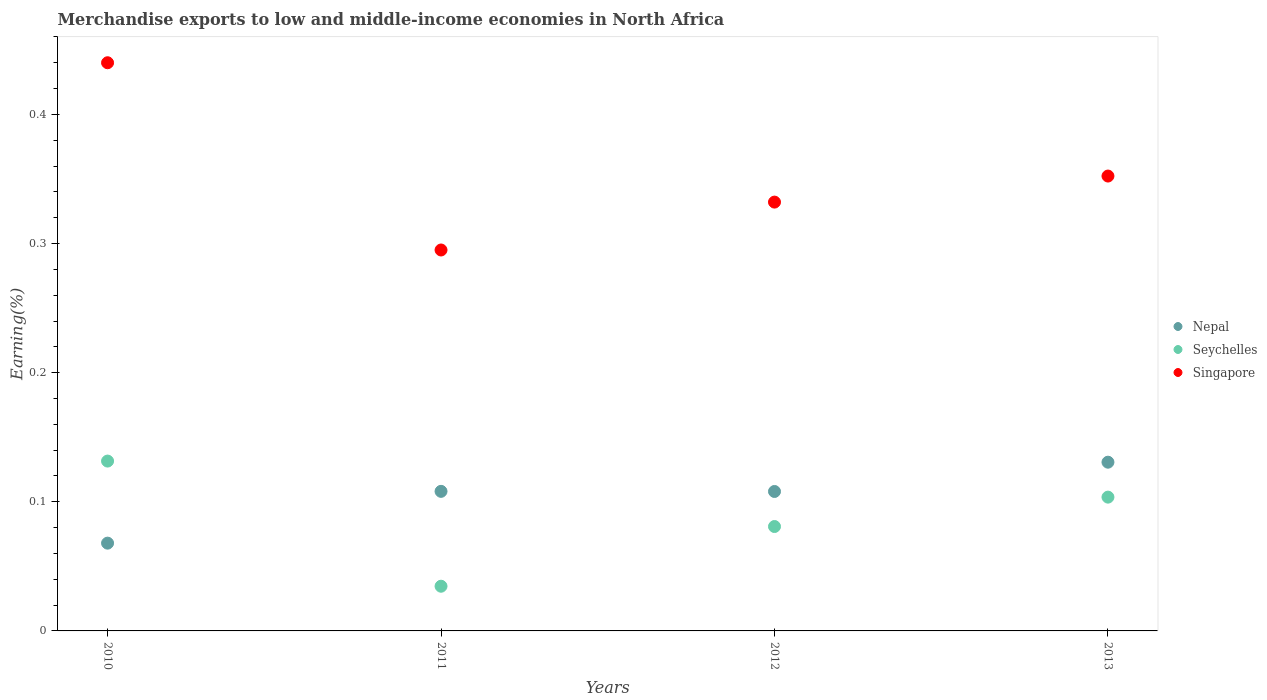How many different coloured dotlines are there?
Keep it short and to the point. 3. What is the percentage of amount earned from merchandise exports in Seychelles in 2013?
Your response must be concise. 0.1. Across all years, what is the maximum percentage of amount earned from merchandise exports in Singapore?
Your answer should be compact. 0.44. Across all years, what is the minimum percentage of amount earned from merchandise exports in Seychelles?
Ensure brevity in your answer.  0.03. In which year was the percentage of amount earned from merchandise exports in Nepal minimum?
Make the answer very short. 2010. What is the total percentage of amount earned from merchandise exports in Singapore in the graph?
Offer a very short reply. 1.42. What is the difference between the percentage of amount earned from merchandise exports in Seychelles in 2012 and that in 2013?
Offer a very short reply. -0.02. What is the difference between the percentage of amount earned from merchandise exports in Seychelles in 2013 and the percentage of amount earned from merchandise exports in Singapore in 2012?
Keep it short and to the point. -0.23. What is the average percentage of amount earned from merchandise exports in Nepal per year?
Ensure brevity in your answer.  0.1. In the year 2010, what is the difference between the percentage of amount earned from merchandise exports in Nepal and percentage of amount earned from merchandise exports in Singapore?
Ensure brevity in your answer.  -0.37. In how many years, is the percentage of amount earned from merchandise exports in Seychelles greater than 0.2 %?
Ensure brevity in your answer.  0. What is the ratio of the percentage of amount earned from merchandise exports in Singapore in 2011 to that in 2013?
Provide a short and direct response. 0.84. Is the difference between the percentage of amount earned from merchandise exports in Nepal in 2011 and 2013 greater than the difference between the percentage of amount earned from merchandise exports in Singapore in 2011 and 2013?
Offer a very short reply. Yes. What is the difference between the highest and the second highest percentage of amount earned from merchandise exports in Singapore?
Ensure brevity in your answer.  0.09. What is the difference between the highest and the lowest percentage of amount earned from merchandise exports in Nepal?
Make the answer very short. 0.06. Is the sum of the percentage of amount earned from merchandise exports in Singapore in 2010 and 2011 greater than the maximum percentage of amount earned from merchandise exports in Seychelles across all years?
Keep it short and to the point. Yes. Is it the case that in every year, the sum of the percentage of amount earned from merchandise exports in Seychelles and percentage of amount earned from merchandise exports in Nepal  is greater than the percentage of amount earned from merchandise exports in Singapore?
Offer a terse response. No. Does the percentage of amount earned from merchandise exports in Singapore monotonically increase over the years?
Give a very brief answer. No. How many dotlines are there?
Offer a terse response. 3. How many years are there in the graph?
Your response must be concise. 4. Are the values on the major ticks of Y-axis written in scientific E-notation?
Make the answer very short. No. Does the graph contain grids?
Your response must be concise. No. Where does the legend appear in the graph?
Offer a very short reply. Center right. What is the title of the graph?
Your response must be concise. Merchandise exports to low and middle-income economies in North Africa. What is the label or title of the X-axis?
Ensure brevity in your answer.  Years. What is the label or title of the Y-axis?
Offer a very short reply. Earning(%). What is the Earning(%) in Nepal in 2010?
Provide a short and direct response. 0.07. What is the Earning(%) in Seychelles in 2010?
Make the answer very short. 0.13. What is the Earning(%) of Singapore in 2010?
Your response must be concise. 0.44. What is the Earning(%) in Nepal in 2011?
Ensure brevity in your answer.  0.11. What is the Earning(%) in Seychelles in 2011?
Offer a very short reply. 0.03. What is the Earning(%) in Singapore in 2011?
Keep it short and to the point. 0.3. What is the Earning(%) of Nepal in 2012?
Your response must be concise. 0.11. What is the Earning(%) of Seychelles in 2012?
Provide a short and direct response. 0.08. What is the Earning(%) in Singapore in 2012?
Provide a short and direct response. 0.33. What is the Earning(%) of Nepal in 2013?
Ensure brevity in your answer.  0.13. What is the Earning(%) in Seychelles in 2013?
Your answer should be very brief. 0.1. What is the Earning(%) of Singapore in 2013?
Ensure brevity in your answer.  0.35. Across all years, what is the maximum Earning(%) in Nepal?
Give a very brief answer. 0.13. Across all years, what is the maximum Earning(%) of Seychelles?
Make the answer very short. 0.13. Across all years, what is the maximum Earning(%) in Singapore?
Offer a very short reply. 0.44. Across all years, what is the minimum Earning(%) of Nepal?
Make the answer very short. 0.07. Across all years, what is the minimum Earning(%) of Seychelles?
Provide a short and direct response. 0.03. Across all years, what is the minimum Earning(%) in Singapore?
Your response must be concise. 0.3. What is the total Earning(%) in Nepal in the graph?
Your response must be concise. 0.41. What is the total Earning(%) in Seychelles in the graph?
Ensure brevity in your answer.  0.35. What is the total Earning(%) of Singapore in the graph?
Your response must be concise. 1.42. What is the difference between the Earning(%) of Nepal in 2010 and that in 2011?
Give a very brief answer. -0.04. What is the difference between the Earning(%) of Seychelles in 2010 and that in 2011?
Provide a succinct answer. 0.1. What is the difference between the Earning(%) in Singapore in 2010 and that in 2011?
Ensure brevity in your answer.  0.14. What is the difference between the Earning(%) of Nepal in 2010 and that in 2012?
Provide a succinct answer. -0.04. What is the difference between the Earning(%) in Seychelles in 2010 and that in 2012?
Give a very brief answer. 0.05. What is the difference between the Earning(%) of Singapore in 2010 and that in 2012?
Ensure brevity in your answer.  0.11. What is the difference between the Earning(%) of Nepal in 2010 and that in 2013?
Ensure brevity in your answer.  -0.06. What is the difference between the Earning(%) in Seychelles in 2010 and that in 2013?
Offer a very short reply. 0.03. What is the difference between the Earning(%) of Singapore in 2010 and that in 2013?
Ensure brevity in your answer.  0.09. What is the difference between the Earning(%) in Nepal in 2011 and that in 2012?
Your answer should be compact. 0. What is the difference between the Earning(%) in Seychelles in 2011 and that in 2012?
Make the answer very short. -0.05. What is the difference between the Earning(%) of Singapore in 2011 and that in 2012?
Provide a succinct answer. -0.04. What is the difference between the Earning(%) of Nepal in 2011 and that in 2013?
Keep it short and to the point. -0.02. What is the difference between the Earning(%) of Seychelles in 2011 and that in 2013?
Ensure brevity in your answer.  -0.07. What is the difference between the Earning(%) in Singapore in 2011 and that in 2013?
Ensure brevity in your answer.  -0.06. What is the difference between the Earning(%) of Nepal in 2012 and that in 2013?
Make the answer very short. -0.02. What is the difference between the Earning(%) of Seychelles in 2012 and that in 2013?
Your answer should be very brief. -0.02. What is the difference between the Earning(%) in Singapore in 2012 and that in 2013?
Provide a short and direct response. -0.02. What is the difference between the Earning(%) in Nepal in 2010 and the Earning(%) in Seychelles in 2011?
Your response must be concise. 0.03. What is the difference between the Earning(%) in Nepal in 2010 and the Earning(%) in Singapore in 2011?
Your answer should be very brief. -0.23. What is the difference between the Earning(%) of Seychelles in 2010 and the Earning(%) of Singapore in 2011?
Provide a succinct answer. -0.16. What is the difference between the Earning(%) in Nepal in 2010 and the Earning(%) in Seychelles in 2012?
Your answer should be very brief. -0.01. What is the difference between the Earning(%) of Nepal in 2010 and the Earning(%) of Singapore in 2012?
Keep it short and to the point. -0.26. What is the difference between the Earning(%) in Seychelles in 2010 and the Earning(%) in Singapore in 2012?
Provide a short and direct response. -0.2. What is the difference between the Earning(%) of Nepal in 2010 and the Earning(%) of Seychelles in 2013?
Keep it short and to the point. -0.04. What is the difference between the Earning(%) in Nepal in 2010 and the Earning(%) in Singapore in 2013?
Keep it short and to the point. -0.28. What is the difference between the Earning(%) in Seychelles in 2010 and the Earning(%) in Singapore in 2013?
Your answer should be compact. -0.22. What is the difference between the Earning(%) of Nepal in 2011 and the Earning(%) of Seychelles in 2012?
Offer a very short reply. 0.03. What is the difference between the Earning(%) of Nepal in 2011 and the Earning(%) of Singapore in 2012?
Make the answer very short. -0.22. What is the difference between the Earning(%) in Seychelles in 2011 and the Earning(%) in Singapore in 2012?
Offer a very short reply. -0.3. What is the difference between the Earning(%) of Nepal in 2011 and the Earning(%) of Seychelles in 2013?
Offer a very short reply. 0. What is the difference between the Earning(%) in Nepal in 2011 and the Earning(%) in Singapore in 2013?
Your answer should be very brief. -0.24. What is the difference between the Earning(%) in Seychelles in 2011 and the Earning(%) in Singapore in 2013?
Offer a terse response. -0.32. What is the difference between the Earning(%) in Nepal in 2012 and the Earning(%) in Seychelles in 2013?
Keep it short and to the point. 0. What is the difference between the Earning(%) in Nepal in 2012 and the Earning(%) in Singapore in 2013?
Your response must be concise. -0.24. What is the difference between the Earning(%) in Seychelles in 2012 and the Earning(%) in Singapore in 2013?
Your answer should be compact. -0.27. What is the average Earning(%) in Nepal per year?
Your response must be concise. 0.1. What is the average Earning(%) in Seychelles per year?
Make the answer very short. 0.09. What is the average Earning(%) of Singapore per year?
Your response must be concise. 0.35. In the year 2010, what is the difference between the Earning(%) of Nepal and Earning(%) of Seychelles?
Your answer should be very brief. -0.06. In the year 2010, what is the difference between the Earning(%) of Nepal and Earning(%) of Singapore?
Your answer should be compact. -0.37. In the year 2010, what is the difference between the Earning(%) in Seychelles and Earning(%) in Singapore?
Ensure brevity in your answer.  -0.31. In the year 2011, what is the difference between the Earning(%) of Nepal and Earning(%) of Seychelles?
Offer a terse response. 0.07. In the year 2011, what is the difference between the Earning(%) in Nepal and Earning(%) in Singapore?
Give a very brief answer. -0.19. In the year 2011, what is the difference between the Earning(%) of Seychelles and Earning(%) of Singapore?
Ensure brevity in your answer.  -0.26. In the year 2012, what is the difference between the Earning(%) in Nepal and Earning(%) in Seychelles?
Offer a very short reply. 0.03. In the year 2012, what is the difference between the Earning(%) of Nepal and Earning(%) of Singapore?
Provide a succinct answer. -0.22. In the year 2012, what is the difference between the Earning(%) in Seychelles and Earning(%) in Singapore?
Provide a succinct answer. -0.25. In the year 2013, what is the difference between the Earning(%) of Nepal and Earning(%) of Seychelles?
Ensure brevity in your answer.  0.03. In the year 2013, what is the difference between the Earning(%) of Nepal and Earning(%) of Singapore?
Your answer should be compact. -0.22. In the year 2013, what is the difference between the Earning(%) of Seychelles and Earning(%) of Singapore?
Your response must be concise. -0.25. What is the ratio of the Earning(%) of Nepal in 2010 to that in 2011?
Give a very brief answer. 0.63. What is the ratio of the Earning(%) of Seychelles in 2010 to that in 2011?
Ensure brevity in your answer.  3.8. What is the ratio of the Earning(%) of Singapore in 2010 to that in 2011?
Your response must be concise. 1.49. What is the ratio of the Earning(%) of Nepal in 2010 to that in 2012?
Keep it short and to the point. 0.63. What is the ratio of the Earning(%) in Seychelles in 2010 to that in 2012?
Make the answer very short. 1.63. What is the ratio of the Earning(%) of Singapore in 2010 to that in 2012?
Your answer should be compact. 1.32. What is the ratio of the Earning(%) of Nepal in 2010 to that in 2013?
Make the answer very short. 0.52. What is the ratio of the Earning(%) of Seychelles in 2010 to that in 2013?
Offer a terse response. 1.27. What is the ratio of the Earning(%) in Singapore in 2010 to that in 2013?
Give a very brief answer. 1.25. What is the ratio of the Earning(%) in Nepal in 2011 to that in 2012?
Make the answer very short. 1. What is the ratio of the Earning(%) in Seychelles in 2011 to that in 2012?
Provide a short and direct response. 0.43. What is the ratio of the Earning(%) of Singapore in 2011 to that in 2012?
Give a very brief answer. 0.89. What is the ratio of the Earning(%) in Nepal in 2011 to that in 2013?
Offer a very short reply. 0.83. What is the ratio of the Earning(%) of Seychelles in 2011 to that in 2013?
Your answer should be very brief. 0.33. What is the ratio of the Earning(%) in Singapore in 2011 to that in 2013?
Provide a succinct answer. 0.84. What is the ratio of the Earning(%) of Nepal in 2012 to that in 2013?
Keep it short and to the point. 0.83. What is the ratio of the Earning(%) in Seychelles in 2012 to that in 2013?
Provide a succinct answer. 0.78. What is the ratio of the Earning(%) in Singapore in 2012 to that in 2013?
Your response must be concise. 0.94. What is the difference between the highest and the second highest Earning(%) of Nepal?
Your answer should be compact. 0.02. What is the difference between the highest and the second highest Earning(%) in Seychelles?
Your response must be concise. 0.03. What is the difference between the highest and the second highest Earning(%) in Singapore?
Make the answer very short. 0.09. What is the difference between the highest and the lowest Earning(%) of Nepal?
Your answer should be compact. 0.06. What is the difference between the highest and the lowest Earning(%) in Seychelles?
Provide a short and direct response. 0.1. What is the difference between the highest and the lowest Earning(%) in Singapore?
Your answer should be compact. 0.14. 